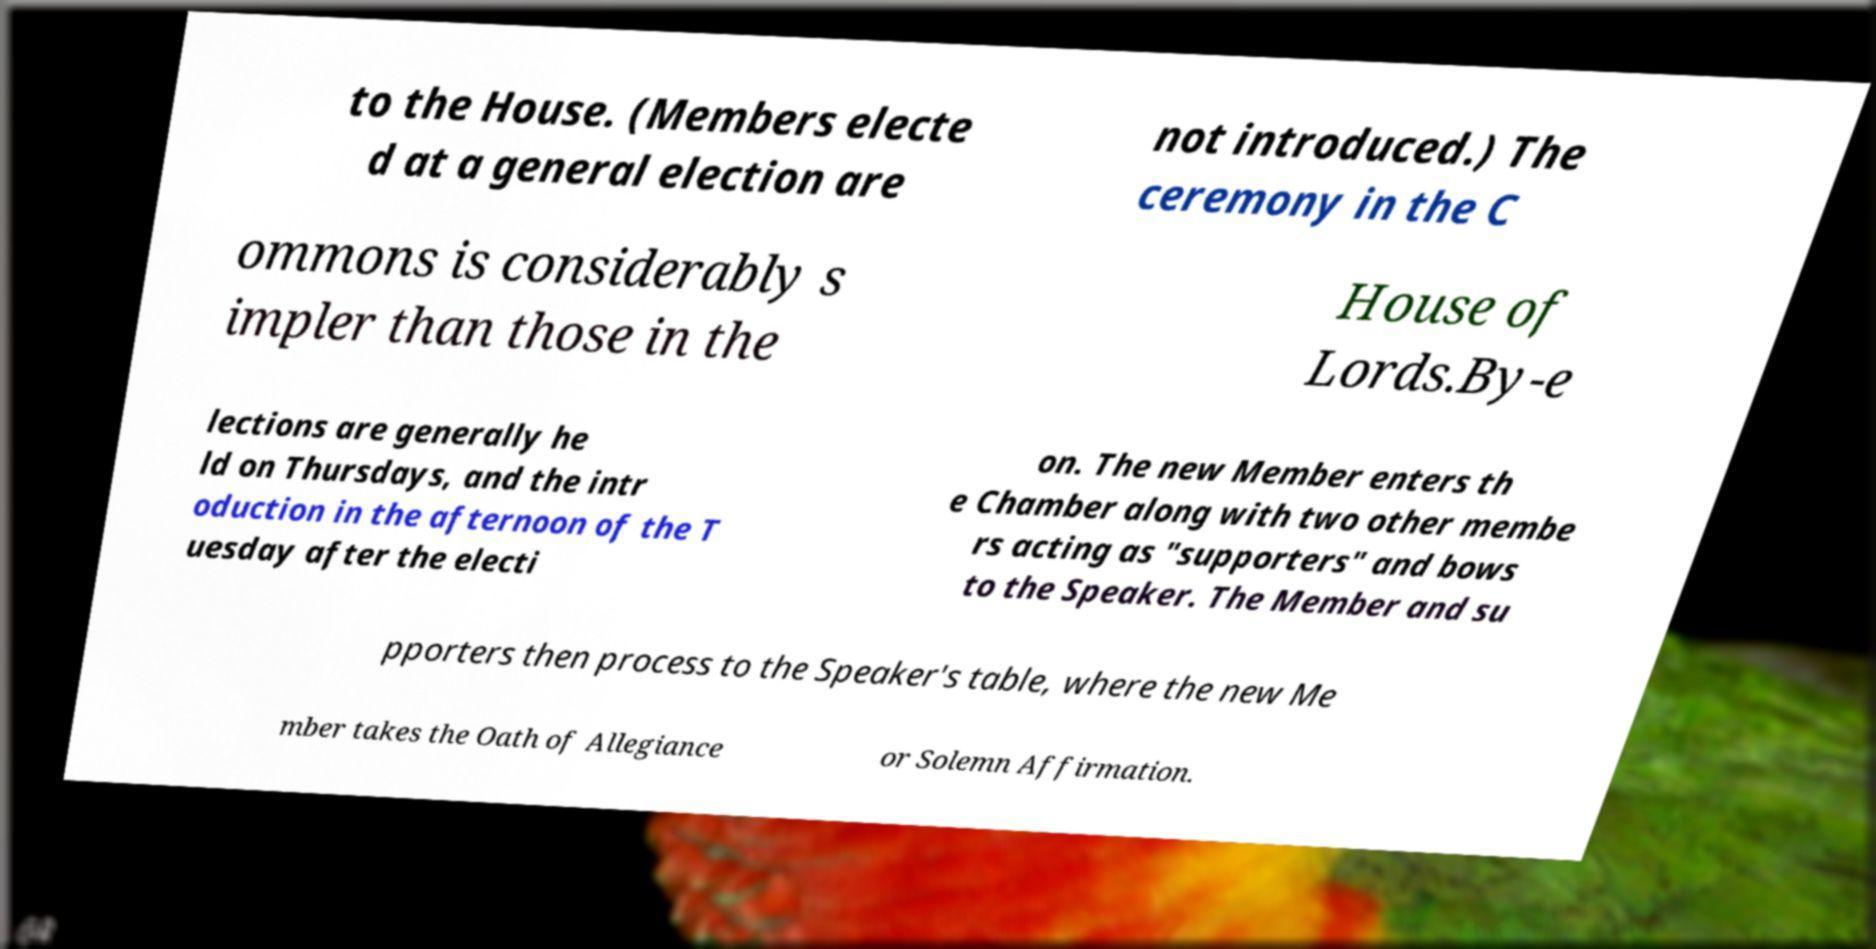Could you assist in decoding the text presented in this image and type it out clearly? to the House. (Members electe d at a general election are not introduced.) The ceremony in the C ommons is considerably s impler than those in the House of Lords.By-e lections are generally he ld on Thursdays, and the intr oduction in the afternoon of the T uesday after the electi on. The new Member enters th e Chamber along with two other membe rs acting as "supporters" and bows to the Speaker. The Member and su pporters then process to the Speaker's table, where the new Me mber takes the Oath of Allegiance or Solemn Affirmation. 